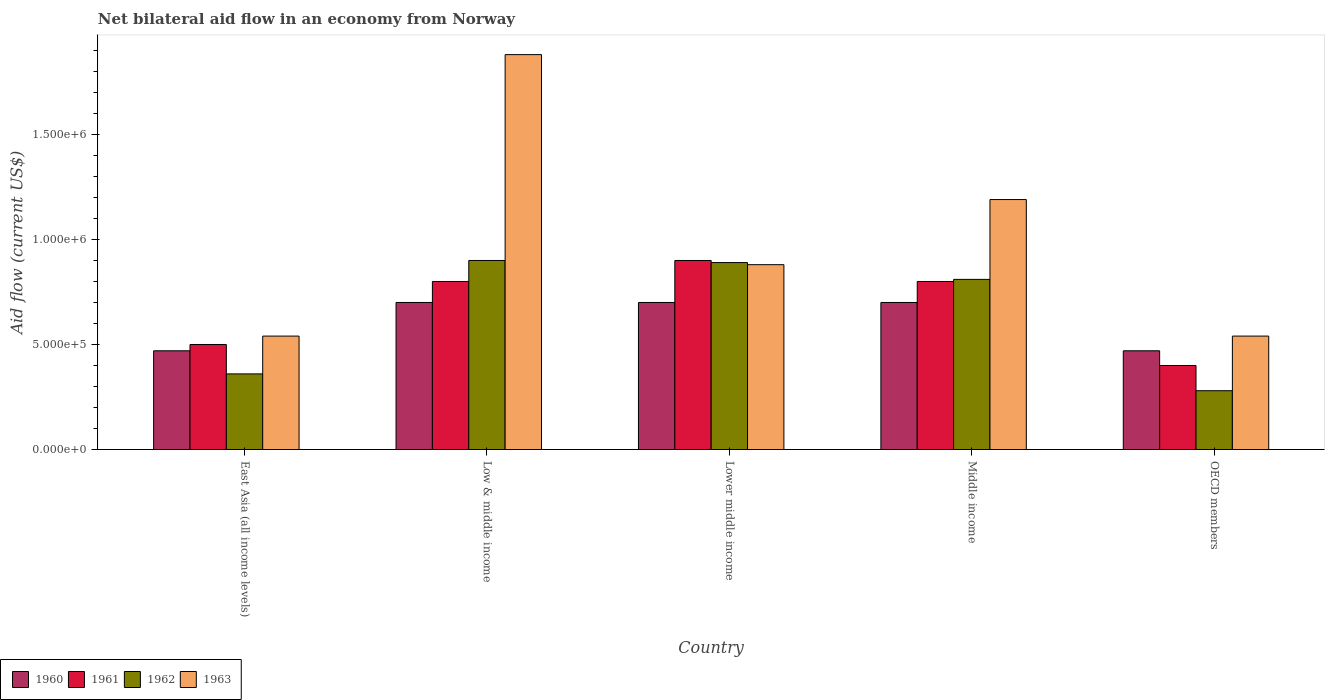How many groups of bars are there?
Your answer should be very brief. 5. Are the number of bars per tick equal to the number of legend labels?
Your answer should be very brief. Yes. How many bars are there on the 4th tick from the left?
Provide a succinct answer. 4. What is the label of the 1st group of bars from the left?
Provide a succinct answer. East Asia (all income levels). What is the net bilateral aid flow in 1962 in East Asia (all income levels)?
Your answer should be compact. 3.60e+05. Across all countries, what is the minimum net bilateral aid flow in 1961?
Provide a short and direct response. 4.00e+05. In which country was the net bilateral aid flow in 1960 minimum?
Make the answer very short. East Asia (all income levels). What is the total net bilateral aid flow in 1961 in the graph?
Provide a succinct answer. 3.40e+06. What is the difference between the net bilateral aid flow in 1960 in East Asia (all income levels) and the net bilateral aid flow in 1963 in OECD members?
Keep it short and to the point. -7.00e+04. What is the average net bilateral aid flow in 1963 per country?
Provide a succinct answer. 1.01e+06. What is the difference between the net bilateral aid flow of/in 1960 and net bilateral aid flow of/in 1963 in Middle income?
Provide a succinct answer. -4.90e+05. In how many countries, is the net bilateral aid flow in 1963 greater than 200000 US$?
Offer a terse response. 5. Is the difference between the net bilateral aid flow in 1960 in East Asia (all income levels) and Middle income greater than the difference between the net bilateral aid flow in 1963 in East Asia (all income levels) and Middle income?
Keep it short and to the point. Yes. What is the difference between the highest and the second highest net bilateral aid flow in 1962?
Your answer should be compact. 9.00e+04. What is the difference between the highest and the lowest net bilateral aid flow in 1962?
Your answer should be very brief. 6.20e+05. Is the sum of the net bilateral aid flow in 1961 in Low & middle income and Middle income greater than the maximum net bilateral aid flow in 1962 across all countries?
Provide a succinct answer. Yes. What does the 1st bar from the left in Middle income represents?
Give a very brief answer. 1960. Are all the bars in the graph horizontal?
Offer a terse response. No. How many countries are there in the graph?
Offer a terse response. 5. What is the difference between two consecutive major ticks on the Y-axis?
Your answer should be very brief. 5.00e+05. Does the graph contain any zero values?
Your answer should be compact. No. Does the graph contain grids?
Ensure brevity in your answer.  No. How many legend labels are there?
Your answer should be very brief. 4. What is the title of the graph?
Offer a very short reply. Net bilateral aid flow in an economy from Norway. Does "1980" appear as one of the legend labels in the graph?
Make the answer very short. No. What is the label or title of the X-axis?
Offer a very short reply. Country. What is the Aid flow (current US$) of 1961 in East Asia (all income levels)?
Your answer should be very brief. 5.00e+05. What is the Aid flow (current US$) of 1963 in East Asia (all income levels)?
Keep it short and to the point. 5.40e+05. What is the Aid flow (current US$) of 1962 in Low & middle income?
Provide a short and direct response. 9.00e+05. What is the Aid flow (current US$) of 1963 in Low & middle income?
Ensure brevity in your answer.  1.88e+06. What is the Aid flow (current US$) in 1961 in Lower middle income?
Provide a succinct answer. 9.00e+05. What is the Aid flow (current US$) of 1962 in Lower middle income?
Provide a short and direct response. 8.90e+05. What is the Aid flow (current US$) of 1963 in Lower middle income?
Offer a very short reply. 8.80e+05. What is the Aid flow (current US$) in 1960 in Middle income?
Give a very brief answer. 7.00e+05. What is the Aid flow (current US$) in 1962 in Middle income?
Offer a very short reply. 8.10e+05. What is the Aid flow (current US$) in 1963 in Middle income?
Provide a short and direct response. 1.19e+06. What is the Aid flow (current US$) in 1961 in OECD members?
Provide a succinct answer. 4.00e+05. What is the Aid flow (current US$) of 1962 in OECD members?
Offer a very short reply. 2.80e+05. What is the Aid flow (current US$) of 1963 in OECD members?
Keep it short and to the point. 5.40e+05. Across all countries, what is the maximum Aid flow (current US$) of 1963?
Your response must be concise. 1.88e+06. Across all countries, what is the minimum Aid flow (current US$) in 1961?
Provide a short and direct response. 4.00e+05. Across all countries, what is the minimum Aid flow (current US$) in 1963?
Your answer should be compact. 5.40e+05. What is the total Aid flow (current US$) of 1960 in the graph?
Provide a succinct answer. 3.04e+06. What is the total Aid flow (current US$) in 1961 in the graph?
Provide a succinct answer. 3.40e+06. What is the total Aid flow (current US$) of 1962 in the graph?
Your answer should be compact. 3.24e+06. What is the total Aid flow (current US$) of 1963 in the graph?
Keep it short and to the point. 5.03e+06. What is the difference between the Aid flow (current US$) in 1960 in East Asia (all income levels) and that in Low & middle income?
Your answer should be compact. -2.30e+05. What is the difference between the Aid flow (current US$) of 1962 in East Asia (all income levels) and that in Low & middle income?
Make the answer very short. -5.40e+05. What is the difference between the Aid flow (current US$) of 1963 in East Asia (all income levels) and that in Low & middle income?
Provide a short and direct response. -1.34e+06. What is the difference between the Aid flow (current US$) in 1960 in East Asia (all income levels) and that in Lower middle income?
Give a very brief answer. -2.30e+05. What is the difference between the Aid flow (current US$) of 1961 in East Asia (all income levels) and that in Lower middle income?
Make the answer very short. -4.00e+05. What is the difference between the Aid flow (current US$) of 1962 in East Asia (all income levels) and that in Lower middle income?
Offer a very short reply. -5.30e+05. What is the difference between the Aid flow (current US$) of 1963 in East Asia (all income levels) and that in Lower middle income?
Keep it short and to the point. -3.40e+05. What is the difference between the Aid flow (current US$) of 1960 in East Asia (all income levels) and that in Middle income?
Ensure brevity in your answer.  -2.30e+05. What is the difference between the Aid flow (current US$) of 1961 in East Asia (all income levels) and that in Middle income?
Provide a short and direct response. -3.00e+05. What is the difference between the Aid flow (current US$) in 1962 in East Asia (all income levels) and that in Middle income?
Your answer should be compact. -4.50e+05. What is the difference between the Aid flow (current US$) of 1963 in East Asia (all income levels) and that in Middle income?
Keep it short and to the point. -6.50e+05. What is the difference between the Aid flow (current US$) in 1960 in East Asia (all income levels) and that in OECD members?
Make the answer very short. 0. What is the difference between the Aid flow (current US$) in 1961 in East Asia (all income levels) and that in OECD members?
Your answer should be very brief. 1.00e+05. What is the difference between the Aid flow (current US$) in 1963 in East Asia (all income levels) and that in OECD members?
Give a very brief answer. 0. What is the difference between the Aid flow (current US$) in 1960 in Low & middle income and that in Lower middle income?
Provide a succinct answer. 0. What is the difference between the Aid flow (current US$) in 1963 in Low & middle income and that in Lower middle income?
Provide a succinct answer. 1.00e+06. What is the difference between the Aid flow (current US$) in 1961 in Low & middle income and that in Middle income?
Give a very brief answer. 0. What is the difference between the Aid flow (current US$) of 1963 in Low & middle income and that in Middle income?
Your answer should be compact. 6.90e+05. What is the difference between the Aid flow (current US$) of 1960 in Low & middle income and that in OECD members?
Keep it short and to the point. 2.30e+05. What is the difference between the Aid flow (current US$) of 1961 in Low & middle income and that in OECD members?
Your answer should be very brief. 4.00e+05. What is the difference between the Aid flow (current US$) in 1962 in Low & middle income and that in OECD members?
Ensure brevity in your answer.  6.20e+05. What is the difference between the Aid flow (current US$) of 1963 in Low & middle income and that in OECD members?
Provide a succinct answer. 1.34e+06. What is the difference between the Aid flow (current US$) of 1961 in Lower middle income and that in Middle income?
Your answer should be very brief. 1.00e+05. What is the difference between the Aid flow (current US$) of 1962 in Lower middle income and that in Middle income?
Provide a succinct answer. 8.00e+04. What is the difference between the Aid flow (current US$) of 1963 in Lower middle income and that in Middle income?
Offer a terse response. -3.10e+05. What is the difference between the Aid flow (current US$) in 1960 in Lower middle income and that in OECD members?
Offer a terse response. 2.30e+05. What is the difference between the Aid flow (current US$) in 1961 in Lower middle income and that in OECD members?
Give a very brief answer. 5.00e+05. What is the difference between the Aid flow (current US$) in 1962 in Lower middle income and that in OECD members?
Provide a succinct answer. 6.10e+05. What is the difference between the Aid flow (current US$) in 1962 in Middle income and that in OECD members?
Provide a short and direct response. 5.30e+05. What is the difference between the Aid flow (current US$) in 1963 in Middle income and that in OECD members?
Make the answer very short. 6.50e+05. What is the difference between the Aid flow (current US$) in 1960 in East Asia (all income levels) and the Aid flow (current US$) in 1961 in Low & middle income?
Your answer should be very brief. -3.30e+05. What is the difference between the Aid flow (current US$) of 1960 in East Asia (all income levels) and the Aid flow (current US$) of 1962 in Low & middle income?
Your answer should be very brief. -4.30e+05. What is the difference between the Aid flow (current US$) of 1960 in East Asia (all income levels) and the Aid flow (current US$) of 1963 in Low & middle income?
Offer a very short reply. -1.41e+06. What is the difference between the Aid flow (current US$) of 1961 in East Asia (all income levels) and the Aid flow (current US$) of 1962 in Low & middle income?
Ensure brevity in your answer.  -4.00e+05. What is the difference between the Aid flow (current US$) of 1961 in East Asia (all income levels) and the Aid flow (current US$) of 1963 in Low & middle income?
Keep it short and to the point. -1.38e+06. What is the difference between the Aid flow (current US$) in 1962 in East Asia (all income levels) and the Aid flow (current US$) in 1963 in Low & middle income?
Offer a very short reply. -1.52e+06. What is the difference between the Aid flow (current US$) in 1960 in East Asia (all income levels) and the Aid flow (current US$) in 1961 in Lower middle income?
Offer a very short reply. -4.30e+05. What is the difference between the Aid flow (current US$) in 1960 in East Asia (all income levels) and the Aid flow (current US$) in 1962 in Lower middle income?
Your answer should be very brief. -4.20e+05. What is the difference between the Aid flow (current US$) in 1960 in East Asia (all income levels) and the Aid flow (current US$) in 1963 in Lower middle income?
Offer a very short reply. -4.10e+05. What is the difference between the Aid flow (current US$) in 1961 in East Asia (all income levels) and the Aid flow (current US$) in 1962 in Lower middle income?
Offer a terse response. -3.90e+05. What is the difference between the Aid flow (current US$) of 1961 in East Asia (all income levels) and the Aid flow (current US$) of 1963 in Lower middle income?
Make the answer very short. -3.80e+05. What is the difference between the Aid flow (current US$) in 1962 in East Asia (all income levels) and the Aid flow (current US$) in 1963 in Lower middle income?
Give a very brief answer. -5.20e+05. What is the difference between the Aid flow (current US$) of 1960 in East Asia (all income levels) and the Aid flow (current US$) of 1961 in Middle income?
Offer a terse response. -3.30e+05. What is the difference between the Aid flow (current US$) in 1960 in East Asia (all income levels) and the Aid flow (current US$) in 1962 in Middle income?
Offer a very short reply. -3.40e+05. What is the difference between the Aid flow (current US$) in 1960 in East Asia (all income levels) and the Aid flow (current US$) in 1963 in Middle income?
Your answer should be very brief. -7.20e+05. What is the difference between the Aid flow (current US$) of 1961 in East Asia (all income levels) and the Aid flow (current US$) of 1962 in Middle income?
Provide a succinct answer. -3.10e+05. What is the difference between the Aid flow (current US$) of 1961 in East Asia (all income levels) and the Aid flow (current US$) of 1963 in Middle income?
Offer a very short reply. -6.90e+05. What is the difference between the Aid flow (current US$) of 1962 in East Asia (all income levels) and the Aid flow (current US$) of 1963 in Middle income?
Provide a succinct answer. -8.30e+05. What is the difference between the Aid flow (current US$) of 1961 in East Asia (all income levels) and the Aid flow (current US$) of 1962 in OECD members?
Offer a very short reply. 2.20e+05. What is the difference between the Aid flow (current US$) of 1961 in East Asia (all income levels) and the Aid flow (current US$) of 1963 in OECD members?
Make the answer very short. -4.00e+04. What is the difference between the Aid flow (current US$) in 1960 in Low & middle income and the Aid flow (current US$) in 1961 in Lower middle income?
Offer a very short reply. -2.00e+05. What is the difference between the Aid flow (current US$) in 1960 in Low & middle income and the Aid flow (current US$) in 1963 in Lower middle income?
Offer a terse response. -1.80e+05. What is the difference between the Aid flow (current US$) of 1961 in Low & middle income and the Aid flow (current US$) of 1963 in Lower middle income?
Your answer should be very brief. -8.00e+04. What is the difference between the Aid flow (current US$) of 1962 in Low & middle income and the Aid flow (current US$) of 1963 in Lower middle income?
Keep it short and to the point. 2.00e+04. What is the difference between the Aid flow (current US$) of 1960 in Low & middle income and the Aid flow (current US$) of 1961 in Middle income?
Your answer should be compact. -1.00e+05. What is the difference between the Aid flow (current US$) in 1960 in Low & middle income and the Aid flow (current US$) in 1962 in Middle income?
Ensure brevity in your answer.  -1.10e+05. What is the difference between the Aid flow (current US$) in 1960 in Low & middle income and the Aid flow (current US$) in 1963 in Middle income?
Offer a terse response. -4.90e+05. What is the difference between the Aid flow (current US$) in 1961 in Low & middle income and the Aid flow (current US$) in 1963 in Middle income?
Your answer should be very brief. -3.90e+05. What is the difference between the Aid flow (current US$) in 1962 in Low & middle income and the Aid flow (current US$) in 1963 in Middle income?
Your answer should be very brief. -2.90e+05. What is the difference between the Aid flow (current US$) of 1961 in Low & middle income and the Aid flow (current US$) of 1962 in OECD members?
Your response must be concise. 5.20e+05. What is the difference between the Aid flow (current US$) in 1962 in Low & middle income and the Aid flow (current US$) in 1963 in OECD members?
Your response must be concise. 3.60e+05. What is the difference between the Aid flow (current US$) of 1960 in Lower middle income and the Aid flow (current US$) of 1963 in Middle income?
Your answer should be compact. -4.90e+05. What is the difference between the Aid flow (current US$) of 1961 in Lower middle income and the Aid flow (current US$) of 1962 in Middle income?
Provide a short and direct response. 9.00e+04. What is the difference between the Aid flow (current US$) of 1961 in Lower middle income and the Aid flow (current US$) of 1963 in Middle income?
Make the answer very short. -2.90e+05. What is the difference between the Aid flow (current US$) in 1962 in Lower middle income and the Aid flow (current US$) in 1963 in Middle income?
Ensure brevity in your answer.  -3.00e+05. What is the difference between the Aid flow (current US$) of 1960 in Lower middle income and the Aid flow (current US$) of 1962 in OECD members?
Give a very brief answer. 4.20e+05. What is the difference between the Aid flow (current US$) in 1960 in Lower middle income and the Aid flow (current US$) in 1963 in OECD members?
Provide a succinct answer. 1.60e+05. What is the difference between the Aid flow (current US$) of 1961 in Lower middle income and the Aid flow (current US$) of 1962 in OECD members?
Ensure brevity in your answer.  6.20e+05. What is the difference between the Aid flow (current US$) in 1962 in Lower middle income and the Aid flow (current US$) in 1963 in OECD members?
Ensure brevity in your answer.  3.50e+05. What is the difference between the Aid flow (current US$) in 1960 in Middle income and the Aid flow (current US$) in 1961 in OECD members?
Make the answer very short. 3.00e+05. What is the difference between the Aid flow (current US$) of 1961 in Middle income and the Aid flow (current US$) of 1962 in OECD members?
Your answer should be compact. 5.20e+05. What is the difference between the Aid flow (current US$) in 1962 in Middle income and the Aid flow (current US$) in 1963 in OECD members?
Make the answer very short. 2.70e+05. What is the average Aid flow (current US$) of 1960 per country?
Provide a short and direct response. 6.08e+05. What is the average Aid flow (current US$) in 1961 per country?
Give a very brief answer. 6.80e+05. What is the average Aid flow (current US$) in 1962 per country?
Your answer should be very brief. 6.48e+05. What is the average Aid flow (current US$) in 1963 per country?
Provide a succinct answer. 1.01e+06. What is the difference between the Aid flow (current US$) of 1960 and Aid flow (current US$) of 1962 in East Asia (all income levels)?
Your answer should be compact. 1.10e+05. What is the difference between the Aid flow (current US$) of 1960 and Aid flow (current US$) of 1963 in East Asia (all income levels)?
Ensure brevity in your answer.  -7.00e+04. What is the difference between the Aid flow (current US$) in 1961 and Aid flow (current US$) in 1962 in East Asia (all income levels)?
Give a very brief answer. 1.40e+05. What is the difference between the Aid flow (current US$) in 1962 and Aid flow (current US$) in 1963 in East Asia (all income levels)?
Give a very brief answer. -1.80e+05. What is the difference between the Aid flow (current US$) in 1960 and Aid flow (current US$) in 1961 in Low & middle income?
Offer a terse response. -1.00e+05. What is the difference between the Aid flow (current US$) of 1960 and Aid flow (current US$) of 1962 in Low & middle income?
Offer a terse response. -2.00e+05. What is the difference between the Aid flow (current US$) of 1960 and Aid flow (current US$) of 1963 in Low & middle income?
Keep it short and to the point. -1.18e+06. What is the difference between the Aid flow (current US$) in 1961 and Aid flow (current US$) in 1963 in Low & middle income?
Give a very brief answer. -1.08e+06. What is the difference between the Aid flow (current US$) in 1962 and Aid flow (current US$) in 1963 in Low & middle income?
Provide a short and direct response. -9.80e+05. What is the difference between the Aid flow (current US$) of 1960 and Aid flow (current US$) of 1963 in Lower middle income?
Make the answer very short. -1.80e+05. What is the difference between the Aid flow (current US$) of 1961 and Aid flow (current US$) of 1962 in Lower middle income?
Your answer should be compact. 10000. What is the difference between the Aid flow (current US$) of 1961 and Aid flow (current US$) of 1963 in Lower middle income?
Keep it short and to the point. 2.00e+04. What is the difference between the Aid flow (current US$) of 1960 and Aid flow (current US$) of 1961 in Middle income?
Keep it short and to the point. -1.00e+05. What is the difference between the Aid flow (current US$) of 1960 and Aid flow (current US$) of 1963 in Middle income?
Make the answer very short. -4.90e+05. What is the difference between the Aid flow (current US$) of 1961 and Aid flow (current US$) of 1963 in Middle income?
Offer a very short reply. -3.90e+05. What is the difference between the Aid flow (current US$) of 1962 and Aid flow (current US$) of 1963 in Middle income?
Offer a terse response. -3.80e+05. What is the difference between the Aid flow (current US$) of 1960 and Aid flow (current US$) of 1961 in OECD members?
Ensure brevity in your answer.  7.00e+04. What is the difference between the Aid flow (current US$) of 1960 and Aid flow (current US$) of 1963 in OECD members?
Your response must be concise. -7.00e+04. What is the difference between the Aid flow (current US$) of 1961 and Aid flow (current US$) of 1962 in OECD members?
Your response must be concise. 1.20e+05. What is the difference between the Aid flow (current US$) of 1961 and Aid flow (current US$) of 1963 in OECD members?
Offer a very short reply. -1.40e+05. What is the difference between the Aid flow (current US$) in 1962 and Aid flow (current US$) in 1963 in OECD members?
Your response must be concise. -2.60e+05. What is the ratio of the Aid flow (current US$) in 1960 in East Asia (all income levels) to that in Low & middle income?
Your answer should be very brief. 0.67. What is the ratio of the Aid flow (current US$) of 1963 in East Asia (all income levels) to that in Low & middle income?
Make the answer very short. 0.29. What is the ratio of the Aid flow (current US$) of 1960 in East Asia (all income levels) to that in Lower middle income?
Your answer should be compact. 0.67. What is the ratio of the Aid flow (current US$) in 1961 in East Asia (all income levels) to that in Lower middle income?
Provide a short and direct response. 0.56. What is the ratio of the Aid flow (current US$) in 1962 in East Asia (all income levels) to that in Lower middle income?
Your answer should be compact. 0.4. What is the ratio of the Aid flow (current US$) in 1963 in East Asia (all income levels) to that in Lower middle income?
Your response must be concise. 0.61. What is the ratio of the Aid flow (current US$) in 1960 in East Asia (all income levels) to that in Middle income?
Your response must be concise. 0.67. What is the ratio of the Aid flow (current US$) of 1962 in East Asia (all income levels) to that in Middle income?
Provide a succinct answer. 0.44. What is the ratio of the Aid flow (current US$) in 1963 in East Asia (all income levels) to that in Middle income?
Give a very brief answer. 0.45. What is the ratio of the Aid flow (current US$) of 1961 in East Asia (all income levels) to that in OECD members?
Offer a very short reply. 1.25. What is the ratio of the Aid flow (current US$) of 1963 in East Asia (all income levels) to that in OECD members?
Your answer should be very brief. 1. What is the ratio of the Aid flow (current US$) in 1960 in Low & middle income to that in Lower middle income?
Give a very brief answer. 1. What is the ratio of the Aid flow (current US$) of 1961 in Low & middle income to that in Lower middle income?
Offer a very short reply. 0.89. What is the ratio of the Aid flow (current US$) in 1962 in Low & middle income to that in Lower middle income?
Keep it short and to the point. 1.01. What is the ratio of the Aid flow (current US$) in 1963 in Low & middle income to that in Lower middle income?
Your response must be concise. 2.14. What is the ratio of the Aid flow (current US$) of 1960 in Low & middle income to that in Middle income?
Make the answer very short. 1. What is the ratio of the Aid flow (current US$) of 1963 in Low & middle income to that in Middle income?
Your answer should be compact. 1.58. What is the ratio of the Aid flow (current US$) in 1960 in Low & middle income to that in OECD members?
Keep it short and to the point. 1.49. What is the ratio of the Aid flow (current US$) in 1962 in Low & middle income to that in OECD members?
Your answer should be compact. 3.21. What is the ratio of the Aid flow (current US$) in 1963 in Low & middle income to that in OECD members?
Ensure brevity in your answer.  3.48. What is the ratio of the Aid flow (current US$) of 1962 in Lower middle income to that in Middle income?
Provide a short and direct response. 1.1. What is the ratio of the Aid flow (current US$) in 1963 in Lower middle income to that in Middle income?
Your response must be concise. 0.74. What is the ratio of the Aid flow (current US$) of 1960 in Lower middle income to that in OECD members?
Your answer should be very brief. 1.49. What is the ratio of the Aid flow (current US$) in 1961 in Lower middle income to that in OECD members?
Your answer should be very brief. 2.25. What is the ratio of the Aid flow (current US$) in 1962 in Lower middle income to that in OECD members?
Keep it short and to the point. 3.18. What is the ratio of the Aid flow (current US$) of 1963 in Lower middle income to that in OECD members?
Make the answer very short. 1.63. What is the ratio of the Aid flow (current US$) in 1960 in Middle income to that in OECD members?
Offer a terse response. 1.49. What is the ratio of the Aid flow (current US$) of 1962 in Middle income to that in OECD members?
Provide a short and direct response. 2.89. What is the ratio of the Aid flow (current US$) of 1963 in Middle income to that in OECD members?
Offer a very short reply. 2.2. What is the difference between the highest and the second highest Aid flow (current US$) of 1960?
Offer a very short reply. 0. What is the difference between the highest and the second highest Aid flow (current US$) in 1963?
Provide a short and direct response. 6.90e+05. What is the difference between the highest and the lowest Aid flow (current US$) in 1960?
Your answer should be compact. 2.30e+05. What is the difference between the highest and the lowest Aid flow (current US$) of 1962?
Give a very brief answer. 6.20e+05. What is the difference between the highest and the lowest Aid flow (current US$) in 1963?
Your answer should be compact. 1.34e+06. 